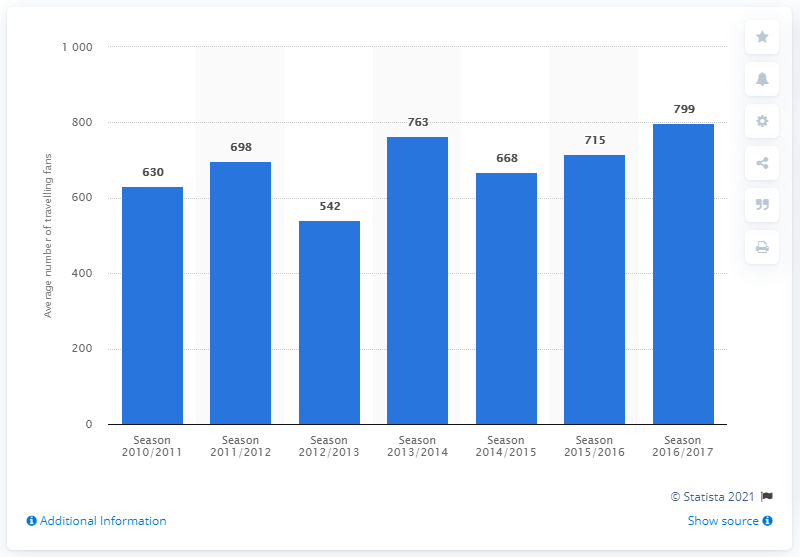List a handful of essential elements in this visual. In the 2016/2017 season, a total of 799 traveling fans were present. 